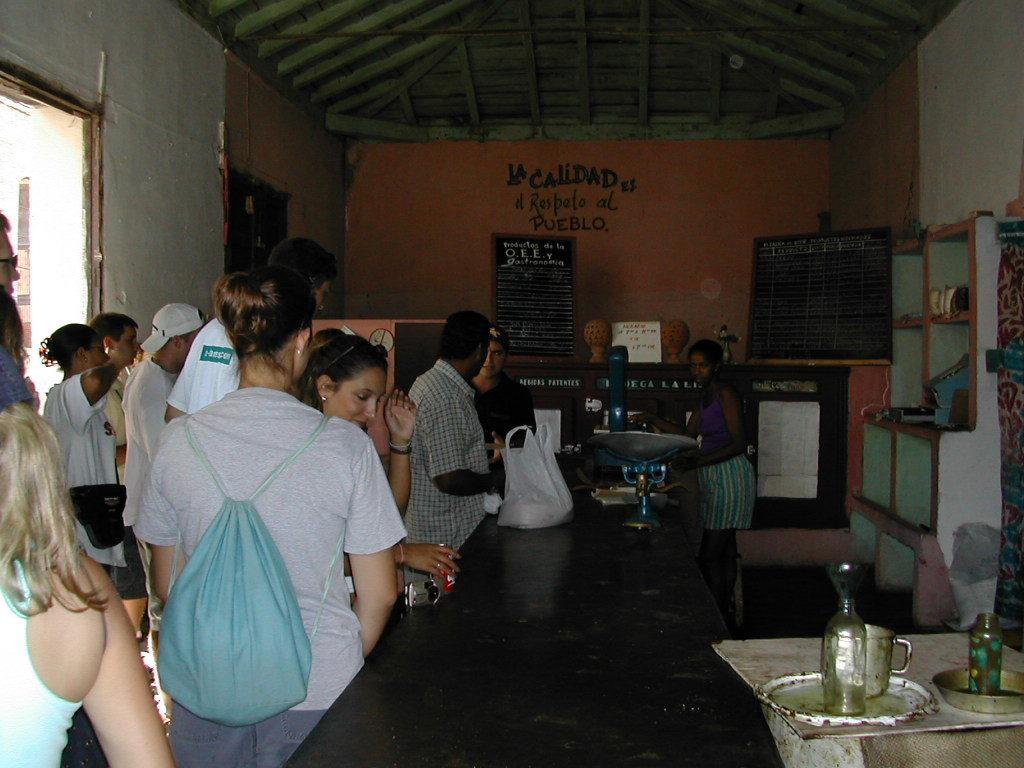What type of establishment is depicted in the image? There is a shop in the image. Can you describe the people in the image? There are people standing in the image. What can be seen in the background of the image? There is a wall in the background of the image. What type of pear is being used as a decoration in the shop? There is no pear present in the image, as it features a shop with people standing and a wall in the background. 